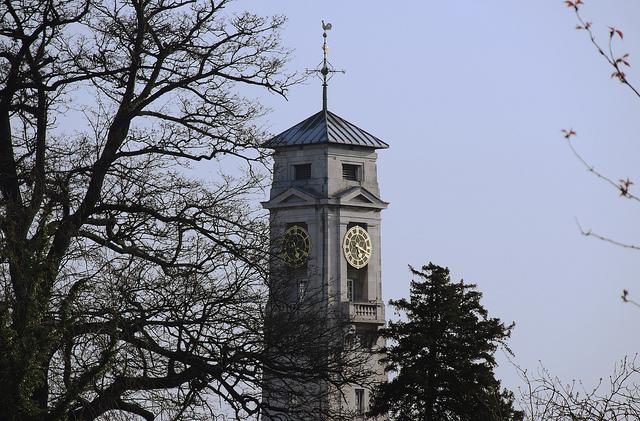What is the object on top of this building?
Answer briefly. Weather vane. Is this indoors?
Be succinct. No. What kind of tree is to the right and in front of the tower?
Answer briefly. Pine. Is this a photo you would see in the Bible?
Answer briefly. No. What is the tower for?
Give a very brief answer. Clock. How many clock faces are there?
Keep it brief. 2. Is this a church?
Short answer required. Yes. What time is displayed on the bell tower?
Write a very short answer. 5:22. 